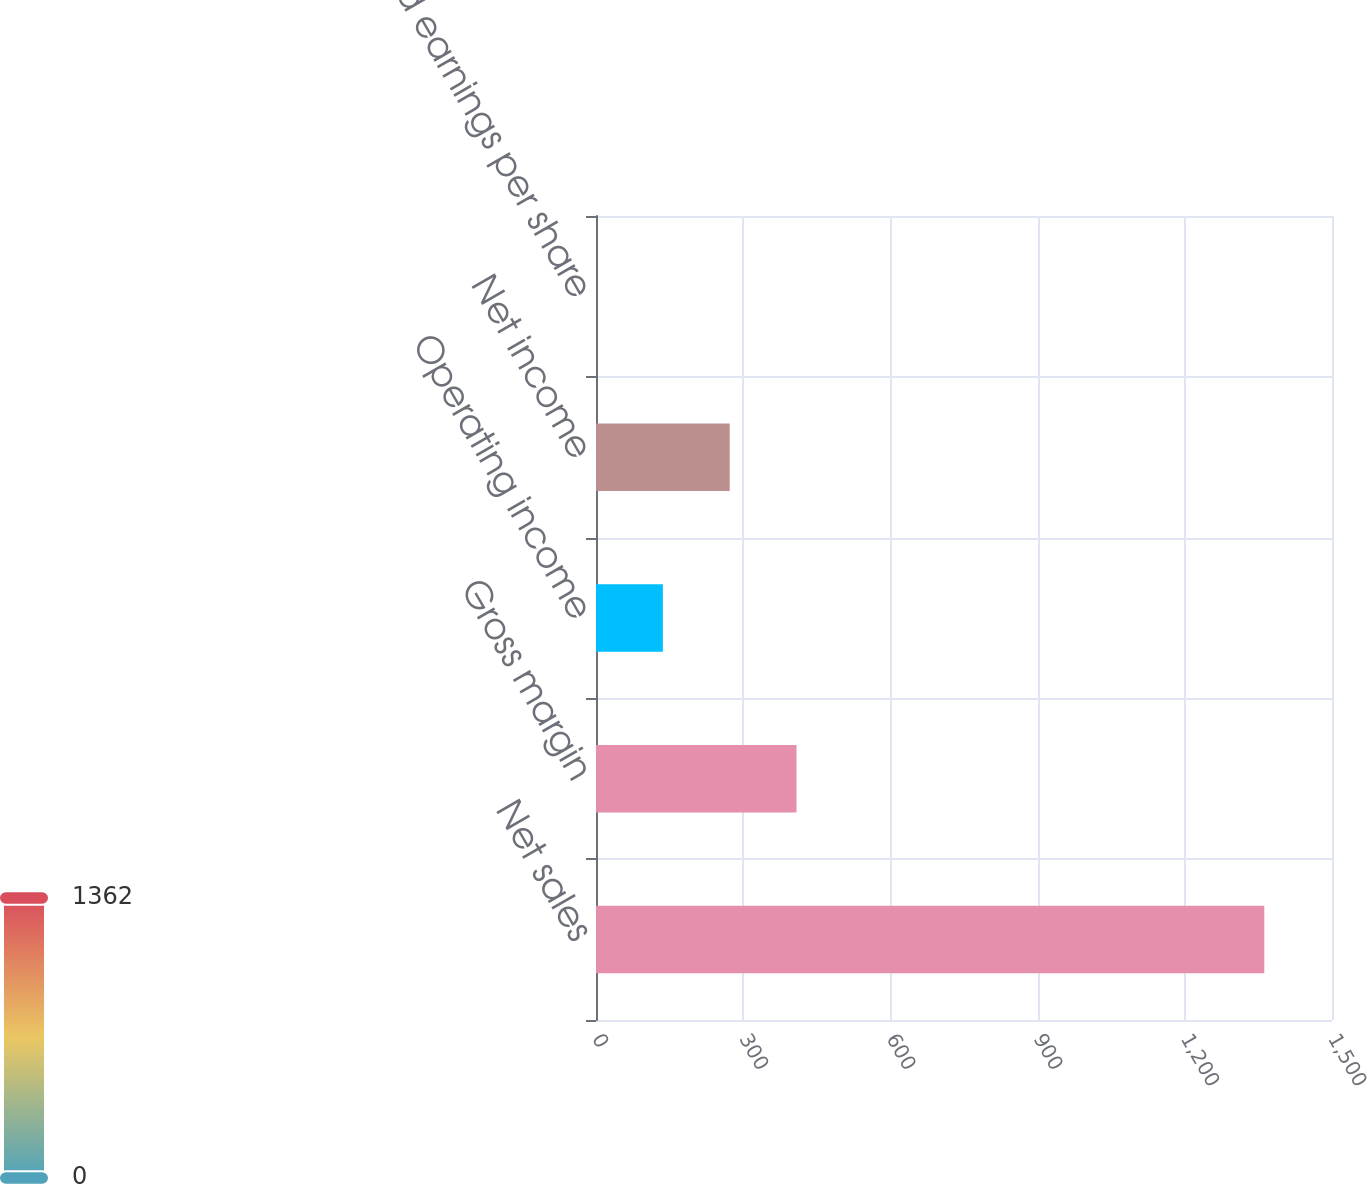<chart> <loc_0><loc_0><loc_500><loc_500><bar_chart><fcel>Net sales<fcel>Gross margin<fcel>Operating income<fcel>Net income<fcel>Diluted earnings per share<nl><fcel>1362<fcel>408.66<fcel>136.28<fcel>272.47<fcel>0.09<nl></chart> 